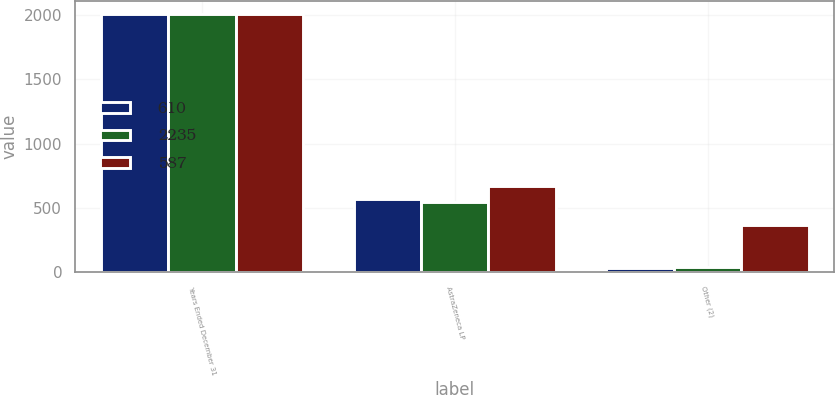<chart> <loc_0><loc_0><loc_500><loc_500><stacked_bar_chart><ecel><fcel>Years Ended December 31<fcel>AstraZeneca LP<fcel>Other (2)<nl><fcel>610<fcel>2011<fcel>574<fcel>36<nl><fcel>2235<fcel>2010<fcel>546<fcel>41<nl><fcel>587<fcel>2009<fcel>674<fcel>366<nl></chart> 